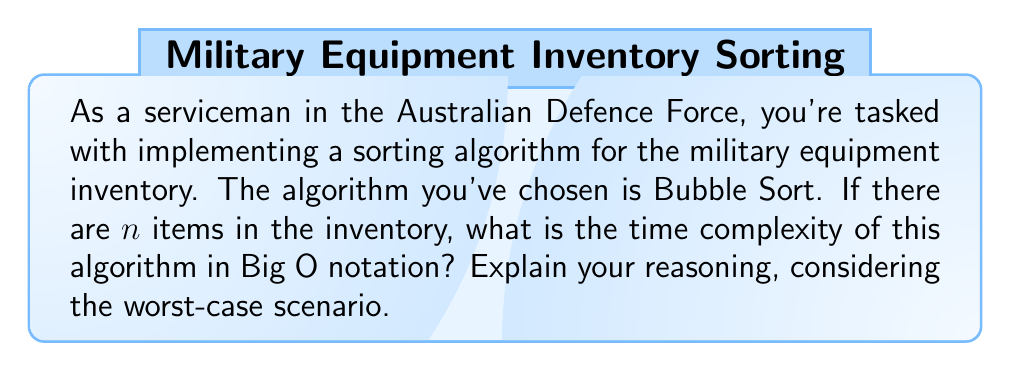Help me with this question. Let's analyze the Bubble Sort algorithm for sorting military equipment inventory:

1) Bubble Sort works by repeatedly stepping through the list, comparing adjacent elements and swapping them if they're in the wrong order.

2) In the worst-case scenario (when the list is in reverse order):

   - The outer loop runs $n-1$ times, where $n$ is the number of items.
   - For each iteration of the outer loop, the inner loop makes $n-i-1$ comparisons, where $i$ is the current iteration of the outer loop.

3) The total number of comparisons is:

   $$(n-1) + (n-2) + (n-3) + ... + 2 + 1 = \frac{n(n-1)}{2}$$

4) This sum can be derived from the arithmetic series formula:
   
   $$\sum_{i=1}^{n-1} i = \frac{n(n-1)}{2}$$

5) In Big O notation, we're concerned with the dominant term as $n$ grows large. Here, the dominant term is $n^2$.

6) Constants and lower-order terms are dropped in Big O notation.

Therefore, the time complexity of Bubble Sort in the worst-case scenario is $O(n^2)$.

This means that as the number of items in the military equipment inventory increases, the time taken by the algorithm increases quadratically.
Answer: $O(n^2)$ 